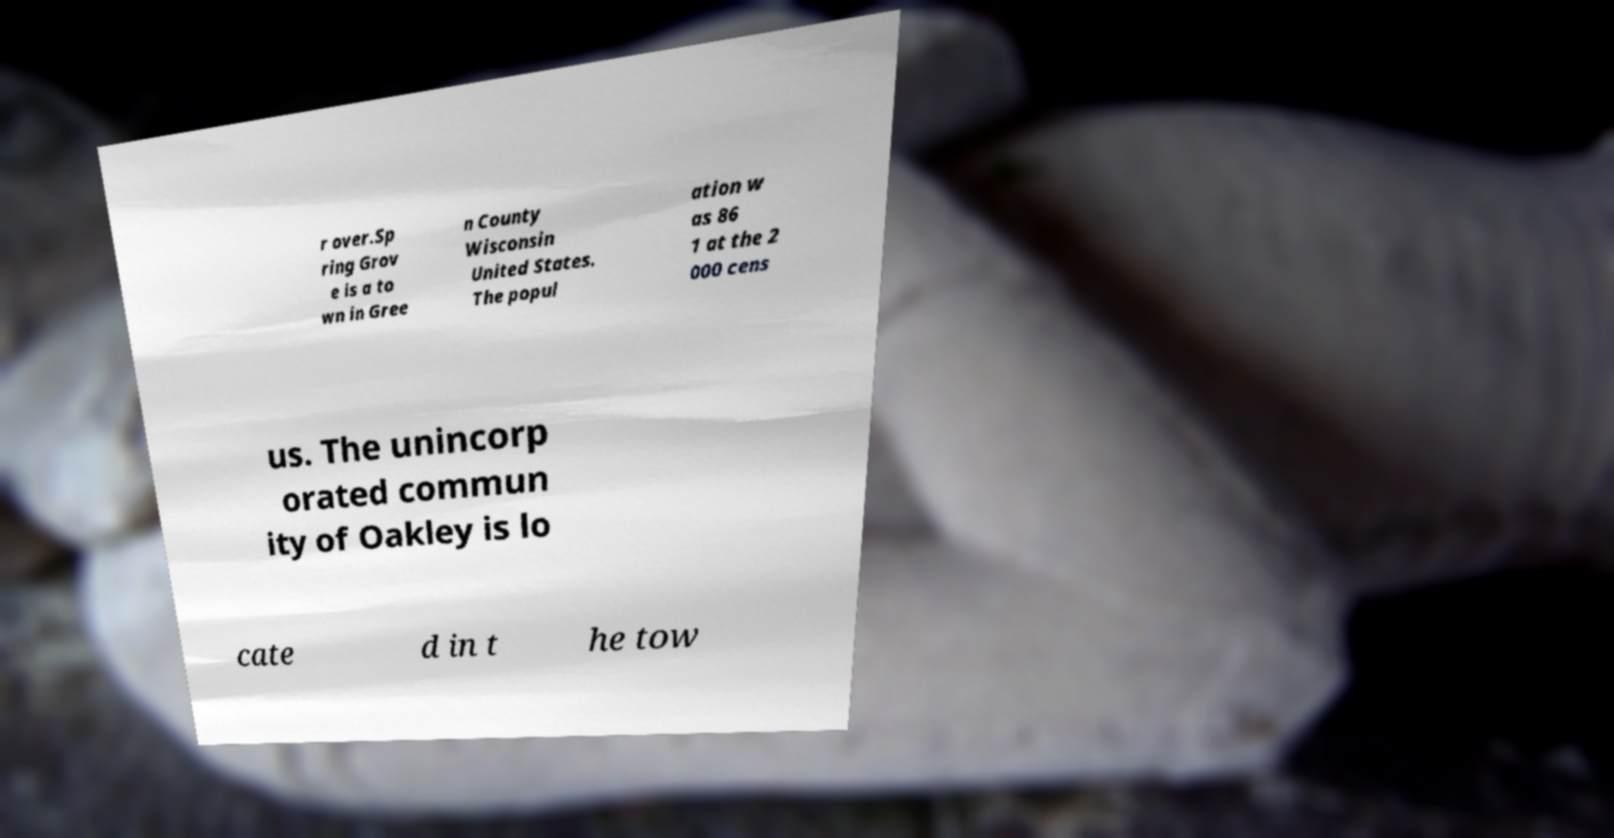I need the written content from this picture converted into text. Can you do that? r over.Sp ring Grov e is a to wn in Gree n County Wisconsin United States. The popul ation w as 86 1 at the 2 000 cens us. The unincorp orated commun ity of Oakley is lo cate d in t he tow 